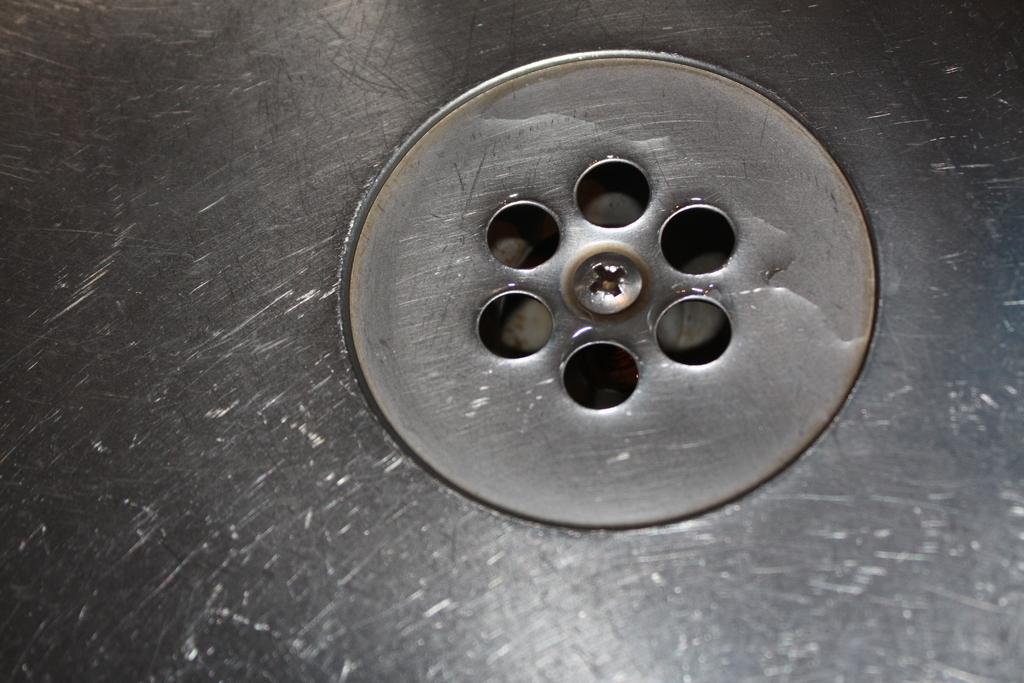Describe this image in one or two sentences. In this image we can see drain holes of a sink. 